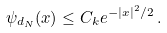<formula> <loc_0><loc_0><loc_500><loc_500>\psi _ { d _ { N } } ( x ) \leq C _ { k } e ^ { - | x | ^ { 2 } / 2 } \, .</formula> 